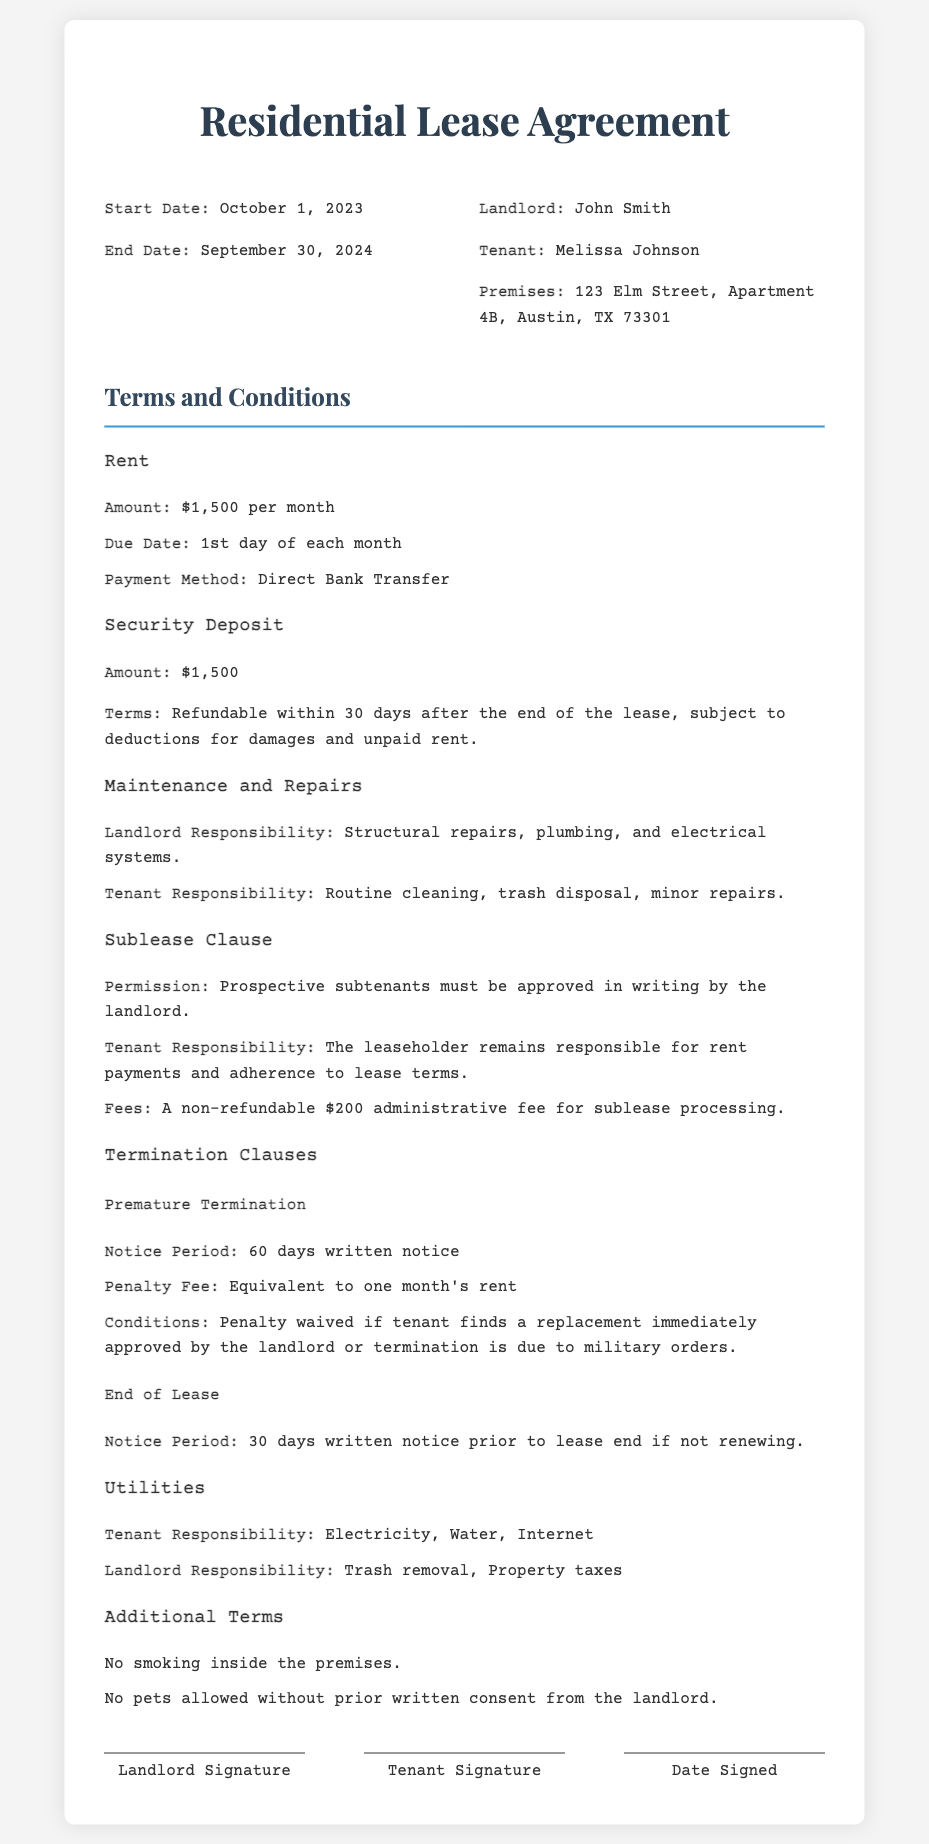What is the monthly rent amount? The document states that the rent amount is a specific figure mentioned in the 'Rent' section.
Answer: $1,500 Who is the landlord? The 'Header Info' section identifies the landlord's name.
Answer: John Smith What is the security deposit amount? The 'Security Deposit' section provides a specific figure related to the deposit.
Answer: $1,500 What is the notice period for premature termination? This notice period is stated in the 'Premature Termination' sub-section under 'Termination Clauses'.
Answer: 60 days What fee is charged for subleasing? The 'Sublease Clause' mentions a specific fee related to the administrative process for subleasing.
Answer: $200 What is required for a tenant to avoid penalty upon premature termination? The 'Premature Termination' clause describes specific conditions under which the penalty can be waived.
Answer: Replacement immediately approved by the landlord What utilities is the tenant responsible for? The 'Utilities' section details the specific costs the tenant is accountable for.
Answer: Electricity, Water, Internet How long is the lease term? The lease term duration can be derived from the dates mentioned in the 'Header Info'.
Answer: 12 months What is the condition for pets in the premises? The 'Additional Terms' section addresses the policy regarding pets in the rental property.
Answer: No pets allowed without prior written consent 